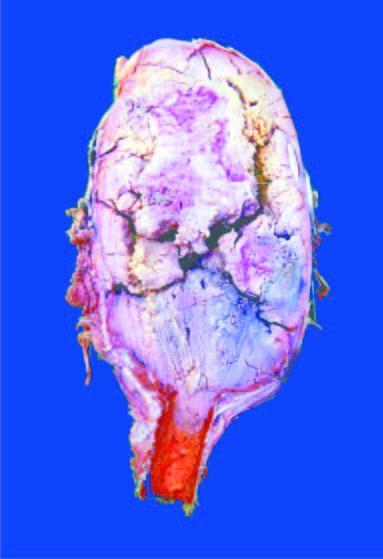what is expanded in the region of epiphysis?
Answer the question using a single word or phrase. End of the long bone 